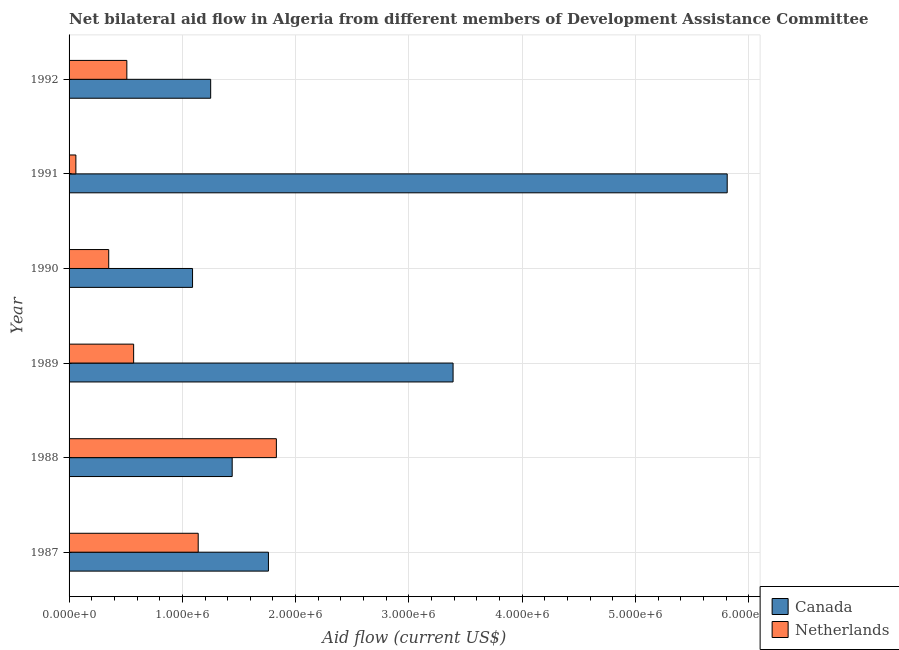How many different coloured bars are there?
Offer a very short reply. 2. How many groups of bars are there?
Your response must be concise. 6. Are the number of bars per tick equal to the number of legend labels?
Keep it short and to the point. Yes. What is the label of the 6th group of bars from the top?
Your response must be concise. 1987. What is the amount of aid given by netherlands in 1988?
Your answer should be very brief. 1.83e+06. Across all years, what is the maximum amount of aid given by netherlands?
Give a very brief answer. 1.83e+06. Across all years, what is the minimum amount of aid given by canada?
Provide a succinct answer. 1.09e+06. In which year was the amount of aid given by canada maximum?
Your answer should be compact. 1991. What is the total amount of aid given by canada in the graph?
Make the answer very short. 1.47e+07. What is the difference between the amount of aid given by netherlands in 1987 and that in 1992?
Provide a succinct answer. 6.30e+05. What is the difference between the amount of aid given by canada in 1987 and the amount of aid given by netherlands in 1989?
Keep it short and to the point. 1.19e+06. What is the average amount of aid given by netherlands per year?
Your answer should be very brief. 7.43e+05. In the year 1992, what is the difference between the amount of aid given by canada and amount of aid given by netherlands?
Your answer should be compact. 7.40e+05. In how many years, is the amount of aid given by canada greater than 3000000 US$?
Your answer should be compact. 2. What is the ratio of the amount of aid given by netherlands in 1991 to that in 1992?
Your response must be concise. 0.12. Is the amount of aid given by canada in 1989 less than that in 1990?
Your response must be concise. No. What is the difference between the highest and the second highest amount of aid given by canada?
Your answer should be very brief. 2.42e+06. What is the difference between the highest and the lowest amount of aid given by netherlands?
Provide a short and direct response. 1.77e+06. Is the sum of the amount of aid given by canada in 1990 and 1992 greater than the maximum amount of aid given by netherlands across all years?
Provide a short and direct response. Yes. What does the 1st bar from the top in 1989 represents?
Your answer should be compact. Netherlands. What does the 1st bar from the bottom in 1988 represents?
Offer a terse response. Canada. Are all the bars in the graph horizontal?
Ensure brevity in your answer.  Yes. What is the difference between two consecutive major ticks on the X-axis?
Offer a very short reply. 1.00e+06. Are the values on the major ticks of X-axis written in scientific E-notation?
Offer a very short reply. Yes. Does the graph contain any zero values?
Provide a succinct answer. No. Does the graph contain grids?
Give a very brief answer. Yes. How are the legend labels stacked?
Offer a terse response. Vertical. What is the title of the graph?
Give a very brief answer. Net bilateral aid flow in Algeria from different members of Development Assistance Committee. What is the Aid flow (current US$) of Canada in 1987?
Ensure brevity in your answer.  1.76e+06. What is the Aid flow (current US$) in Netherlands in 1987?
Make the answer very short. 1.14e+06. What is the Aid flow (current US$) in Canada in 1988?
Keep it short and to the point. 1.44e+06. What is the Aid flow (current US$) of Netherlands in 1988?
Offer a very short reply. 1.83e+06. What is the Aid flow (current US$) in Canada in 1989?
Offer a very short reply. 3.39e+06. What is the Aid flow (current US$) in Netherlands in 1989?
Your answer should be compact. 5.70e+05. What is the Aid flow (current US$) of Canada in 1990?
Ensure brevity in your answer.  1.09e+06. What is the Aid flow (current US$) in Netherlands in 1990?
Your answer should be very brief. 3.50e+05. What is the Aid flow (current US$) in Canada in 1991?
Provide a short and direct response. 5.81e+06. What is the Aid flow (current US$) of Netherlands in 1991?
Provide a short and direct response. 6.00e+04. What is the Aid flow (current US$) of Canada in 1992?
Provide a short and direct response. 1.25e+06. What is the Aid flow (current US$) of Netherlands in 1992?
Your answer should be compact. 5.10e+05. Across all years, what is the maximum Aid flow (current US$) in Canada?
Provide a succinct answer. 5.81e+06. Across all years, what is the maximum Aid flow (current US$) in Netherlands?
Give a very brief answer. 1.83e+06. Across all years, what is the minimum Aid flow (current US$) in Canada?
Give a very brief answer. 1.09e+06. What is the total Aid flow (current US$) of Canada in the graph?
Ensure brevity in your answer.  1.47e+07. What is the total Aid flow (current US$) in Netherlands in the graph?
Keep it short and to the point. 4.46e+06. What is the difference between the Aid flow (current US$) in Canada in 1987 and that in 1988?
Your answer should be compact. 3.20e+05. What is the difference between the Aid flow (current US$) of Netherlands in 1987 and that in 1988?
Keep it short and to the point. -6.90e+05. What is the difference between the Aid flow (current US$) of Canada in 1987 and that in 1989?
Offer a terse response. -1.63e+06. What is the difference between the Aid flow (current US$) in Netherlands in 1987 and that in 1989?
Offer a very short reply. 5.70e+05. What is the difference between the Aid flow (current US$) in Canada in 1987 and that in 1990?
Your answer should be very brief. 6.70e+05. What is the difference between the Aid flow (current US$) in Netherlands in 1987 and that in 1990?
Give a very brief answer. 7.90e+05. What is the difference between the Aid flow (current US$) in Canada in 1987 and that in 1991?
Ensure brevity in your answer.  -4.05e+06. What is the difference between the Aid flow (current US$) in Netherlands in 1987 and that in 1991?
Keep it short and to the point. 1.08e+06. What is the difference between the Aid flow (current US$) of Canada in 1987 and that in 1992?
Give a very brief answer. 5.10e+05. What is the difference between the Aid flow (current US$) in Netherlands in 1987 and that in 1992?
Offer a very short reply. 6.30e+05. What is the difference between the Aid flow (current US$) of Canada in 1988 and that in 1989?
Your answer should be compact. -1.95e+06. What is the difference between the Aid flow (current US$) in Netherlands in 1988 and that in 1989?
Offer a terse response. 1.26e+06. What is the difference between the Aid flow (current US$) in Netherlands in 1988 and that in 1990?
Offer a very short reply. 1.48e+06. What is the difference between the Aid flow (current US$) in Canada in 1988 and that in 1991?
Your answer should be very brief. -4.37e+06. What is the difference between the Aid flow (current US$) in Netherlands in 1988 and that in 1991?
Provide a short and direct response. 1.77e+06. What is the difference between the Aid flow (current US$) of Netherlands in 1988 and that in 1992?
Give a very brief answer. 1.32e+06. What is the difference between the Aid flow (current US$) of Canada in 1989 and that in 1990?
Provide a short and direct response. 2.30e+06. What is the difference between the Aid flow (current US$) in Canada in 1989 and that in 1991?
Offer a terse response. -2.42e+06. What is the difference between the Aid flow (current US$) of Netherlands in 1989 and that in 1991?
Provide a succinct answer. 5.10e+05. What is the difference between the Aid flow (current US$) of Canada in 1989 and that in 1992?
Provide a short and direct response. 2.14e+06. What is the difference between the Aid flow (current US$) of Netherlands in 1989 and that in 1992?
Provide a succinct answer. 6.00e+04. What is the difference between the Aid flow (current US$) in Canada in 1990 and that in 1991?
Your answer should be very brief. -4.72e+06. What is the difference between the Aid flow (current US$) in Canada in 1991 and that in 1992?
Make the answer very short. 4.56e+06. What is the difference between the Aid flow (current US$) of Netherlands in 1991 and that in 1992?
Keep it short and to the point. -4.50e+05. What is the difference between the Aid flow (current US$) of Canada in 1987 and the Aid flow (current US$) of Netherlands in 1989?
Your answer should be compact. 1.19e+06. What is the difference between the Aid flow (current US$) of Canada in 1987 and the Aid flow (current US$) of Netherlands in 1990?
Your answer should be very brief. 1.41e+06. What is the difference between the Aid flow (current US$) of Canada in 1987 and the Aid flow (current US$) of Netherlands in 1991?
Provide a succinct answer. 1.70e+06. What is the difference between the Aid flow (current US$) of Canada in 1987 and the Aid flow (current US$) of Netherlands in 1992?
Give a very brief answer. 1.25e+06. What is the difference between the Aid flow (current US$) of Canada in 1988 and the Aid flow (current US$) of Netherlands in 1989?
Your response must be concise. 8.70e+05. What is the difference between the Aid flow (current US$) in Canada in 1988 and the Aid flow (current US$) in Netherlands in 1990?
Keep it short and to the point. 1.09e+06. What is the difference between the Aid flow (current US$) of Canada in 1988 and the Aid flow (current US$) of Netherlands in 1991?
Your response must be concise. 1.38e+06. What is the difference between the Aid flow (current US$) of Canada in 1988 and the Aid flow (current US$) of Netherlands in 1992?
Provide a short and direct response. 9.30e+05. What is the difference between the Aid flow (current US$) of Canada in 1989 and the Aid flow (current US$) of Netherlands in 1990?
Your answer should be compact. 3.04e+06. What is the difference between the Aid flow (current US$) of Canada in 1989 and the Aid flow (current US$) of Netherlands in 1991?
Provide a succinct answer. 3.33e+06. What is the difference between the Aid flow (current US$) in Canada in 1989 and the Aid flow (current US$) in Netherlands in 1992?
Your answer should be very brief. 2.88e+06. What is the difference between the Aid flow (current US$) of Canada in 1990 and the Aid flow (current US$) of Netherlands in 1991?
Your answer should be very brief. 1.03e+06. What is the difference between the Aid flow (current US$) of Canada in 1990 and the Aid flow (current US$) of Netherlands in 1992?
Your response must be concise. 5.80e+05. What is the difference between the Aid flow (current US$) of Canada in 1991 and the Aid flow (current US$) of Netherlands in 1992?
Ensure brevity in your answer.  5.30e+06. What is the average Aid flow (current US$) in Canada per year?
Offer a terse response. 2.46e+06. What is the average Aid flow (current US$) of Netherlands per year?
Your answer should be very brief. 7.43e+05. In the year 1987, what is the difference between the Aid flow (current US$) in Canada and Aid flow (current US$) in Netherlands?
Keep it short and to the point. 6.20e+05. In the year 1988, what is the difference between the Aid flow (current US$) of Canada and Aid flow (current US$) of Netherlands?
Provide a short and direct response. -3.90e+05. In the year 1989, what is the difference between the Aid flow (current US$) in Canada and Aid flow (current US$) in Netherlands?
Provide a succinct answer. 2.82e+06. In the year 1990, what is the difference between the Aid flow (current US$) of Canada and Aid flow (current US$) of Netherlands?
Give a very brief answer. 7.40e+05. In the year 1991, what is the difference between the Aid flow (current US$) in Canada and Aid flow (current US$) in Netherlands?
Keep it short and to the point. 5.75e+06. In the year 1992, what is the difference between the Aid flow (current US$) in Canada and Aid flow (current US$) in Netherlands?
Your response must be concise. 7.40e+05. What is the ratio of the Aid flow (current US$) of Canada in 1987 to that in 1988?
Your response must be concise. 1.22. What is the ratio of the Aid flow (current US$) of Netherlands in 1987 to that in 1988?
Give a very brief answer. 0.62. What is the ratio of the Aid flow (current US$) of Canada in 1987 to that in 1989?
Provide a short and direct response. 0.52. What is the ratio of the Aid flow (current US$) in Canada in 1987 to that in 1990?
Offer a terse response. 1.61. What is the ratio of the Aid flow (current US$) in Netherlands in 1987 to that in 1990?
Ensure brevity in your answer.  3.26. What is the ratio of the Aid flow (current US$) in Canada in 1987 to that in 1991?
Your answer should be very brief. 0.3. What is the ratio of the Aid flow (current US$) of Netherlands in 1987 to that in 1991?
Give a very brief answer. 19. What is the ratio of the Aid flow (current US$) in Canada in 1987 to that in 1992?
Make the answer very short. 1.41. What is the ratio of the Aid flow (current US$) in Netherlands in 1987 to that in 1992?
Provide a short and direct response. 2.24. What is the ratio of the Aid flow (current US$) of Canada in 1988 to that in 1989?
Provide a short and direct response. 0.42. What is the ratio of the Aid flow (current US$) in Netherlands in 1988 to that in 1989?
Offer a terse response. 3.21. What is the ratio of the Aid flow (current US$) of Canada in 1988 to that in 1990?
Ensure brevity in your answer.  1.32. What is the ratio of the Aid flow (current US$) of Netherlands in 1988 to that in 1990?
Ensure brevity in your answer.  5.23. What is the ratio of the Aid flow (current US$) of Canada in 1988 to that in 1991?
Give a very brief answer. 0.25. What is the ratio of the Aid flow (current US$) in Netherlands in 1988 to that in 1991?
Ensure brevity in your answer.  30.5. What is the ratio of the Aid flow (current US$) of Canada in 1988 to that in 1992?
Offer a very short reply. 1.15. What is the ratio of the Aid flow (current US$) in Netherlands in 1988 to that in 1992?
Your answer should be very brief. 3.59. What is the ratio of the Aid flow (current US$) of Canada in 1989 to that in 1990?
Offer a very short reply. 3.11. What is the ratio of the Aid flow (current US$) in Netherlands in 1989 to that in 1990?
Ensure brevity in your answer.  1.63. What is the ratio of the Aid flow (current US$) of Canada in 1989 to that in 1991?
Give a very brief answer. 0.58. What is the ratio of the Aid flow (current US$) in Netherlands in 1989 to that in 1991?
Offer a terse response. 9.5. What is the ratio of the Aid flow (current US$) in Canada in 1989 to that in 1992?
Provide a short and direct response. 2.71. What is the ratio of the Aid flow (current US$) of Netherlands in 1989 to that in 1992?
Keep it short and to the point. 1.12. What is the ratio of the Aid flow (current US$) in Canada in 1990 to that in 1991?
Offer a very short reply. 0.19. What is the ratio of the Aid flow (current US$) of Netherlands in 1990 to that in 1991?
Your response must be concise. 5.83. What is the ratio of the Aid flow (current US$) in Canada in 1990 to that in 1992?
Offer a very short reply. 0.87. What is the ratio of the Aid flow (current US$) of Netherlands in 1990 to that in 1992?
Keep it short and to the point. 0.69. What is the ratio of the Aid flow (current US$) in Canada in 1991 to that in 1992?
Keep it short and to the point. 4.65. What is the ratio of the Aid flow (current US$) of Netherlands in 1991 to that in 1992?
Ensure brevity in your answer.  0.12. What is the difference between the highest and the second highest Aid flow (current US$) in Canada?
Give a very brief answer. 2.42e+06. What is the difference between the highest and the second highest Aid flow (current US$) of Netherlands?
Give a very brief answer. 6.90e+05. What is the difference between the highest and the lowest Aid flow (current US$) of Canada?
Offer a terse response. 4.72e+06. What is the difference between the highest and the lowest Aid flow (current US$) in Netherlands?
Make the answer very short. 1.77e+06. 